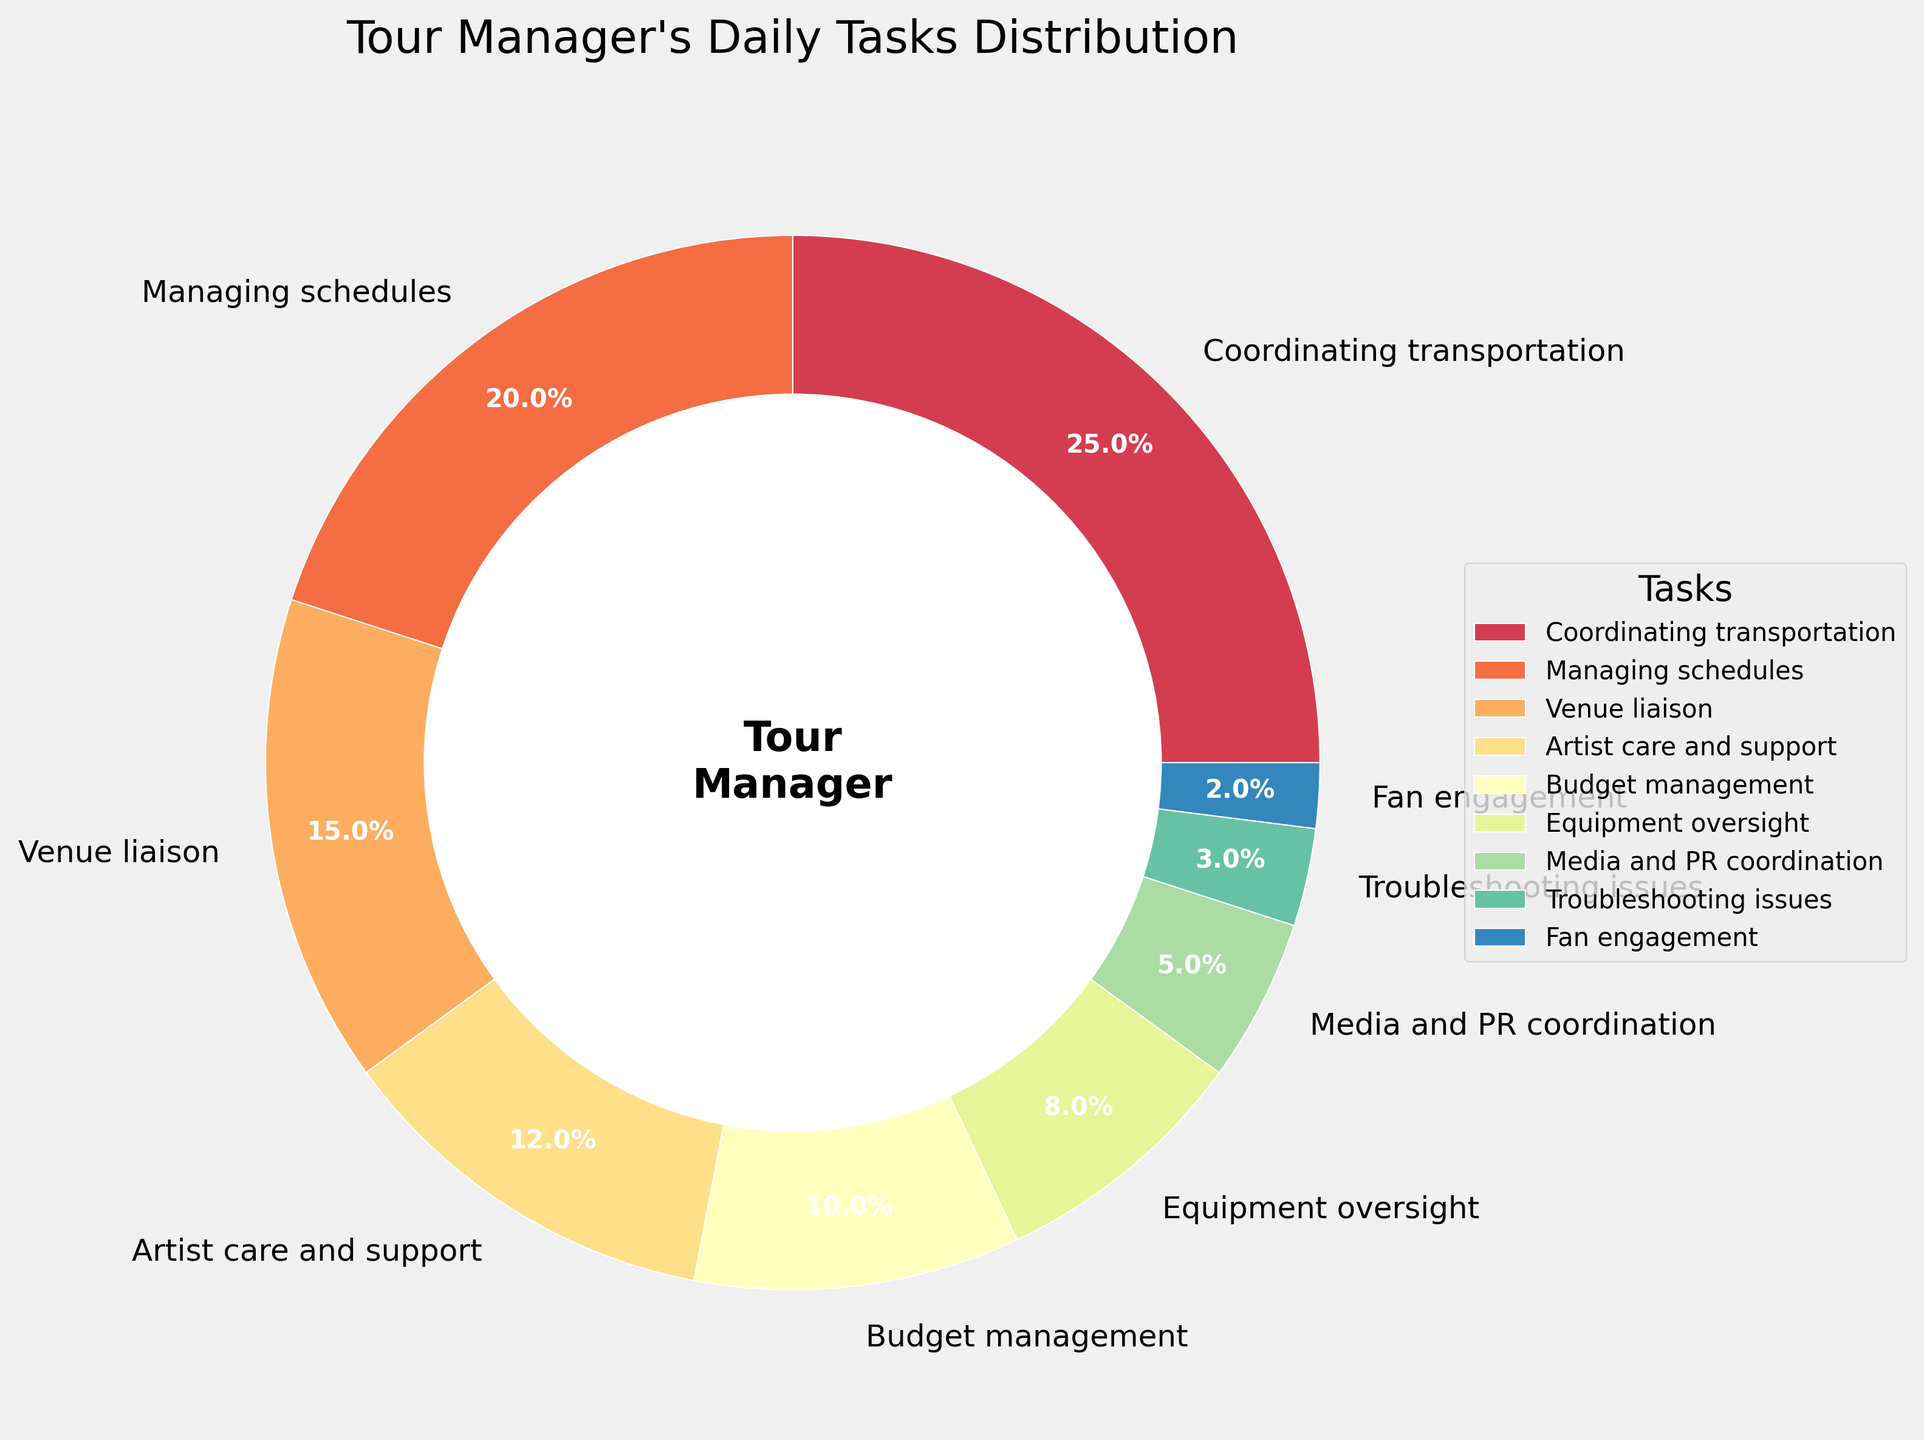Which task takes up the largest percentage of the tour manager's day? From the figure, "Coordinating transportation" occupies the largest segment of the pie chart.
Answer: Coordinating transportation Which two tasks together make up over 40% of the tour manager's daily tasks? "Coordinating transportation" (25%) and "Managing schedules" (20%) together make up 45%, which is over 40%.
Answer: Coordinating transportation and Managing schedules How much more time is spent on "Artist care and support" than on "Troubleshooting issues"? "Artist care and support" takes up 12% while "Troubleshooting issues" takes up 3%. The difference is 12% - 3% = 9%.
Answer: 9% What is the combined percentage of time spent on "Budget management" and "Equipment oversight"? "Budget management" is 10% and "Equipment oversight" is 8%. Together, they make up 10% + 8% = 18%.
Answer: 18% Which task has the smallest share in the tour manager's daily distribution? The smallest segment in the pie chart is "Fan engagement" at 2%.
Answer: Fan engagement Is there any task that makes up exactly a fifth of the tour manager's daily tasks? "Managing schedules" makes up 20%, which is exactly a fifth of the total percentage (100%).
Answer: Managing schedules Are there more tasks that take up less than 10% of the time, or more than 10% of the time? Tasks with less than 10%: "Equipment oversight" (8%), "Media and PR coordination" (5%), "Troubleshooting issues" (3%), "Fan engagement" (2%) = 4 tasks. Tasks with more than 10%: "Coordinating transportation" (25%), "Managing schedules" (20%), "Venue liaison" (15%), "Artist care and support" (12%), "Budget management" (10%) = 5 tasks.
Answer: More than 10% What is the average percentage of time spent on tasks excluding "Coordinating transportation"? Excluding "Coordinating transportation" (25%), the sum of the other percentages is: 20% + 15% + 12% + 10% + 8% + 5% + 3% + 2% = 75%. There are 8 tasks, so the average is 75% / 8 = 9.375%.
Answer: 9.375% 